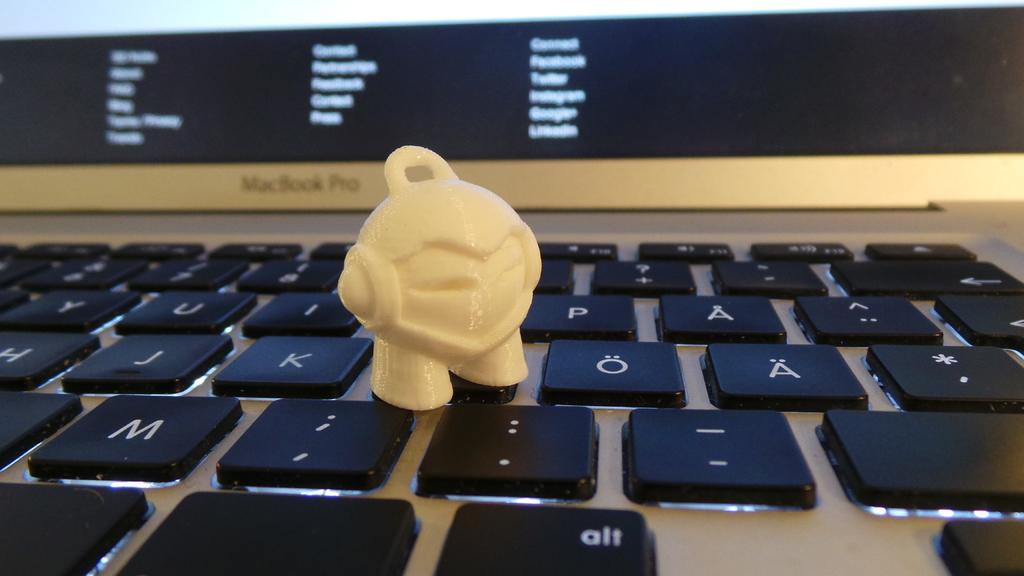What is the button on the bottom right?
Your answer should be compact. Alt. What key is to the left of the figure?
Offer a very short reply. K. 